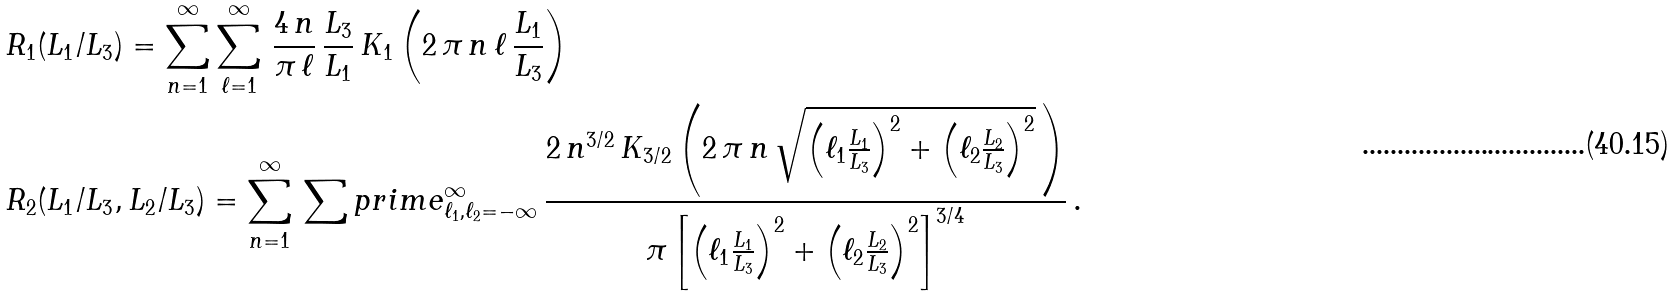Convert formula to latex. <formula><loc_0><loc_0><loc_500><loc_500>& R _ { 1 } ( L _ { 1 } / L _ { 3 } ) = \sum _ { n = 1 } ^ { \infty } \sum _ { \ell = 1 } ^ { \infty } \, \frac { 4 \, n } { \pi \, \ell } \, \frac { L _ { 3 } } { L _ { 1 } } \, K _ { 1 } \left ( 2 \, \pi \, n \, \ell \, \frac { L _ { 1 } } { L _ { 3 } } \right ) \\ & R _ { 2 } ( L _ { 1 } / L _ { 3 } , L _ { 2 } / L _ { 3 } ) = \sum _ { n = 1 } ^ { \infty } \, \sum p r i m e _ { \ell _ { 1 } , \ell _ { 2 } = - \infty } ^ { \infty } \, \frac { 2 \, n ^ { 3 / 2 } \, K _ { 3 / 2 } \left ( 2 \, \pi \, n \, \sqrt { \left ( \ell _ { 1 } \frac { L _ { 1 } } { L _ { 3 } } \right ) ^ { 2 } + \left ( \ell _ { 2 } \frac { L _ { 2 } } { L _ { 3 } } \right ) ^ { 2 } } \, \right ) } { \pi \left [ \left ( \ell _ { 1 } \frac { L _ { 1 } } { L _ { 3 } } \right ) ^ { 2 } + \left ( \ell _ { 2 } \frac { L _ { 2 } } { L _ { 3 } } \right ) ^ { 2 } \right ] ^ { 3 / 4 } } \, .</formula> 